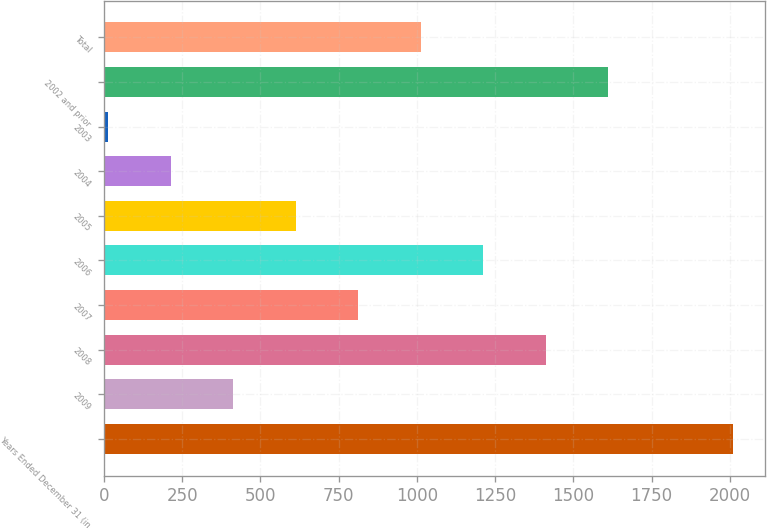<chart> <loc_0><loc_0><loc_500><loc_500><bar_chart><fcel>Years Ended December 31 (in<fcel>2009<fcel>2008<fcel>2007<fcel>2006<fcel>2005<fcel>2004<fcel>2003<fcel>2002 and prior<fcel>Total<nl><fcel>2011<fcel>412.6<fcel>1411.6<fcel>812.2<fcel>1211.8<fcel>612.4<fcel>212.8<fcel>13<fcel>1611.4<fcel>1012<nl></chart> 